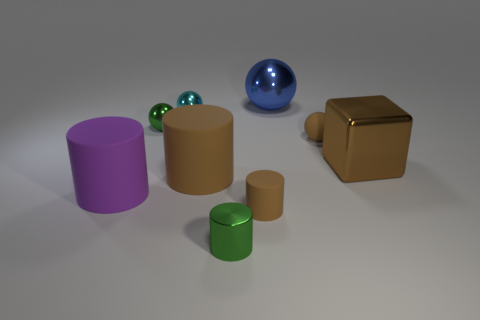What is the material of the blue ball?
Keep it short and to the point. Metal. How many matte things are tiny balls or big purple things?
Offer a very short reply. 2. Is the number of green shiny objects that are left of the small cyan object less than the number of matte cylinders that are behind the large brown rubber object?
Make the answer very short. No. Are there any metal things that are in front of the small green object in front of the large brown object in front of the block?
Make the answer very short. No. What material is the small cylinder that is the same color as the small rubber sphere?
Ensure brevity in your answer.  Rubber. There is a large rubber thing that is to the left of the cyan shiny object; is it the same shape as the small green thing that is to the left of the tiny cyan metallic sphere?
Your answer should be very brief. No. What material is the block that is the same size as the purple rubber object?
Your answer should be compact. Metal. Are the small object that is to the left of the tiny cyan shiny thing and the tiny cylinder that is behind the green cylinder made of the same material?
Your answer should be compact. No. The cyan object that is the same size as the green metallic ball is what shape?
Keep it short and to the point. Sphere. What number of other objects are the same color as the block?
Make the answer very short. 3. 